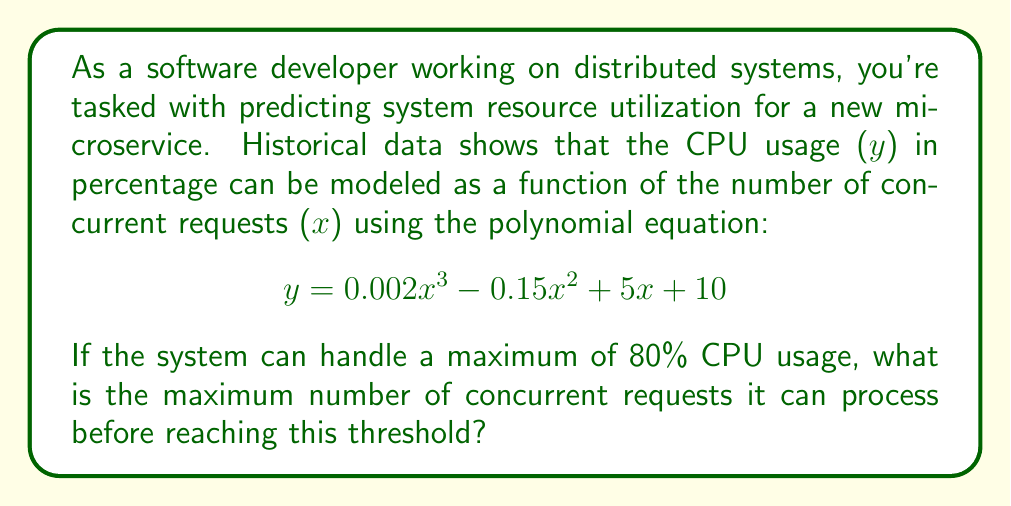Can you solve this math problem? To solve this problem, we need to follow these steps:

1) We're looking for the value of x (concurrent requests) when y (CPU usage) reaches 80%. So, we need to solve the equation:

   $80 = 0.002x^3 - 0.15x^2 + 5x + 10$

2) Rearrange the equation to standard form:

   $0.002x^3 - 0.15x^2 + 5x - 70 = 0$

3) This is a cubic equation. While it can be solved algebraically, it's complex. In a real-world scenario, we'd use numerical methods or software tools. For this example, let's use a graphing method.

4) We can graph $y = 0.002x^3 - 0.15x^2 + 5x - 70$ and find where it intersects the x-axis.

5) Using a graphing tool or calculator, we find that the equation has three roots: approximately -13.8, 50.3, and 138.5.

6) Since we're dealing with the number of concurrent requests, we can discard the negative root. The smaller positive root (50.3) represents where CPU usage first reaches 80%, and the larger root (138.5) is where it drops back to 80% after exceeding it.

7) Therefore, the maximum number of concurrent requests before reaching 80% CPU usage is approximately 50.3.

8) Since we can't have a fractional number of requests, we round down to 50 to ensure we stay under the 80% threshold.
Answer: 50 concurrent requests 